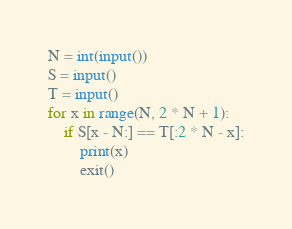<code> <loc_0><loc_0><loc_500><loc_500><_Python_>N = int(input())
S = input()
T = input()
for x in range(N, 2 * N + 1):
    if S[x - N:] == T[:2 * N - x]:
        print(x)
        exit()
</code> 